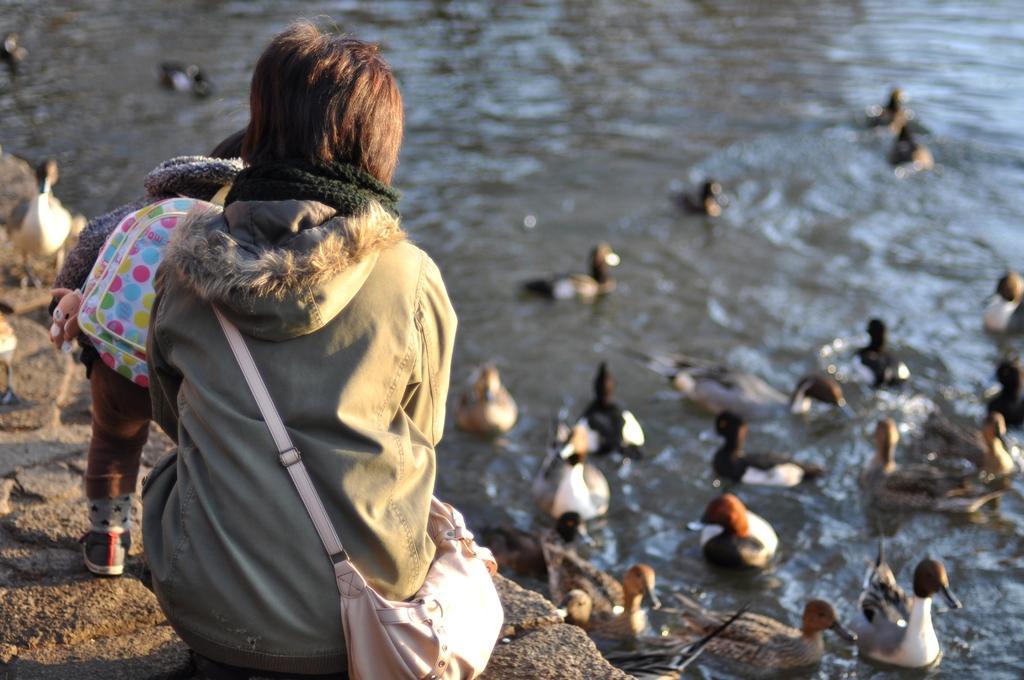How would you summarize this image in a sentence or two? In this picture I can see a kid and a person. I can see two ducks on the rock, and in the background there are ducks in the water. 